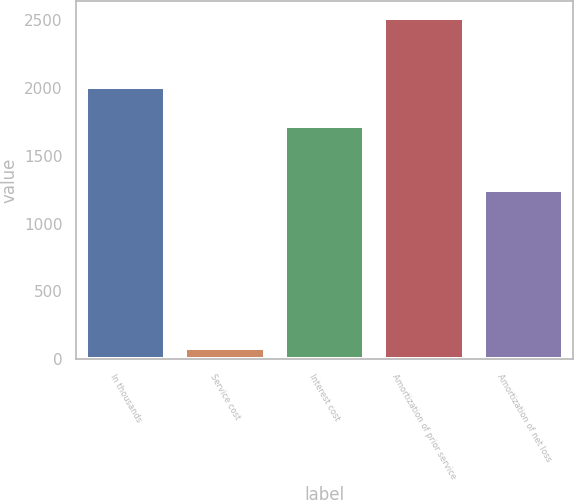Convert chart to OTSL. <chart><loc_0><loc_0><loc_500><loc_500><bar_chart><fcel>In thousands<fcel>Service cost<fcel>Interest cost<fcel>Amortization of prior service<fcel>Amortization of net loss<nl><fcel>2009<fcel>84<fcel>1719<fcel>2515<fcel>1246<nl></chart> 